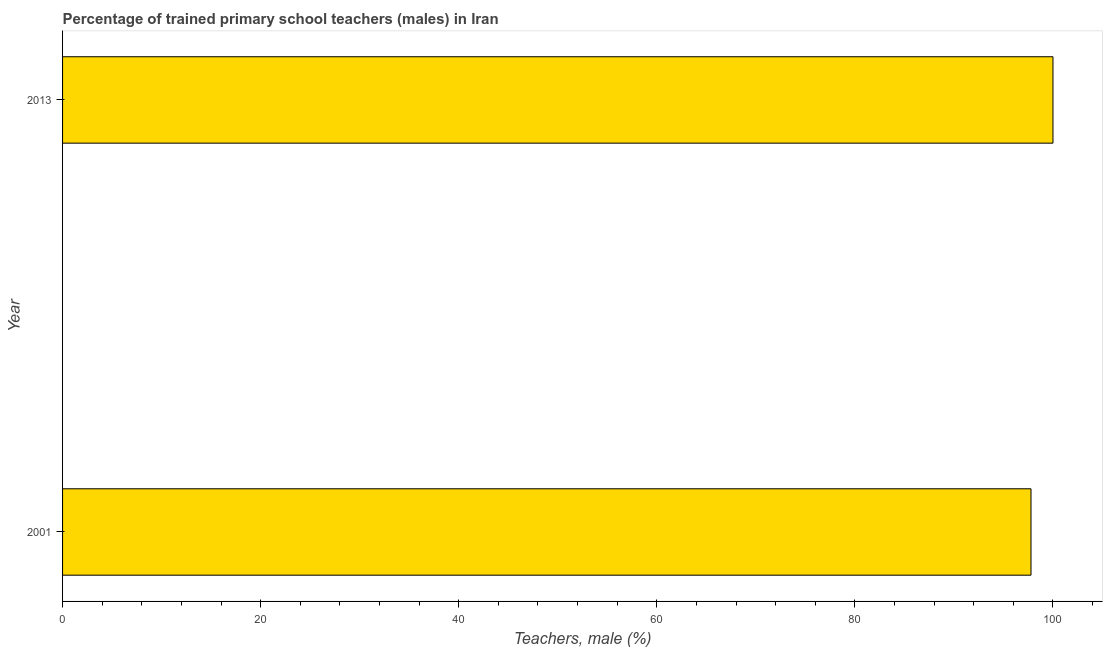What is the title of the graph?
Give a very brief answer. Percentage of trained primary school teachers (males) in Iran. What is the label or title of the X-axis?
Your response must be concise. Teachers, male (%). Across all years, what is the minimum percentage of trained male teachers?
Offer a terse response. 97.78. In which year was the percentage of trained male teachers maximum?
Provide a succinct answer. 2013. What is the sum of the percentage of trained male teachers?
Make the answer very short. 197.78. What is the difference between the percentage of trained male teachers in 2001 and 2013?
Keep it short and to the point. -2.22. What is the average percentage of trained male teachers per year?
Keep it short and to the point. 98.89. What is the median percentage of trained male teachers?
Provide a succinct answer. 98.89. What is the ratio of the percentage of trained male teachers in 2001 to that in 2013?
Your answer should be very brief. 0.98. Is the percentage of trained male teachers in 2001 less than that in 2013?
Give a very brief answer. Yes. In how many years, is the percentage of trained male teachers greater than the average percentage of trained male teachers taken over all years?
Your answer should be very brief. 1. How many bars are there?
Ensure brevity in your answer.  2. How many years are there in the graph?
Keep it short and to the point. 2. What is the Teachers, male (%) of 2001?
Offer a terse response. 97.78. What is the difference between the Teachers, male (%) in 2001 and 2013?
Give a very brief answer. -2.22. What is the ratio of the Teachers, male (%) in 2001 to that in 2013?
Your answer should be compact. 0.98. 